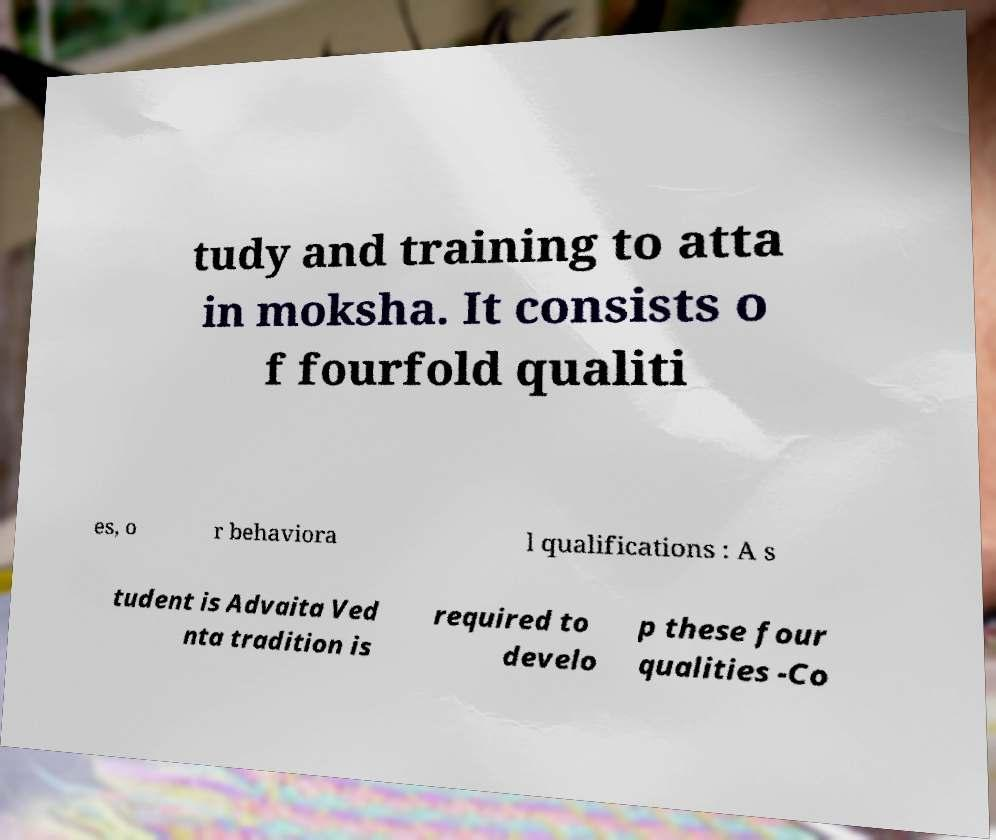Can you accurately transcribe the text from the provided image for me? tudy and training to atta in moksha. It consists o f fourfold qualiti es, o r behaviora l qualifications : A s tudent is Advaita Ved nta tradition is required to develo p these four qualities -Co 